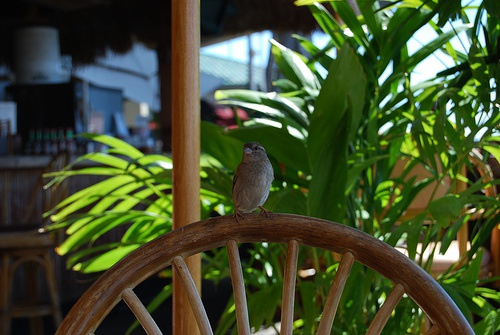Describe the objects in this image and their specific colors. I can see potted plant in black, darkgreen, and olive tones, chair in black, maroon, and gray tones, chair in black, darkgreen, and gray tones, chair in black, blue, and darkblue tones, and bird in black and gray tones in this image. 